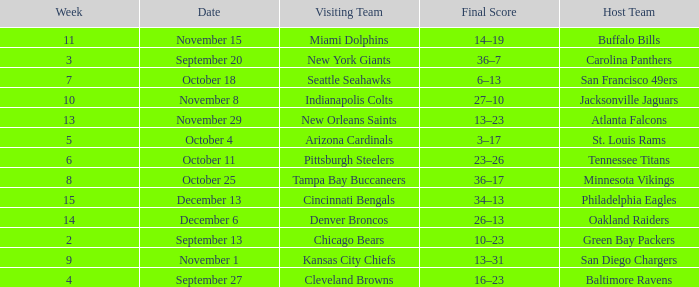What team played on the road against the Buffalo Bills at home ? Miami Dolphins. Could you parse the entire table? {'header': ['Week', 'Date', 'Visiting Team', 'Final Score', 'Host Team'], 'rows': [['11', 'November 15', 'Miami Dolphins', '14–19', 'Buffalo Bills'], ['3', 'September 20', 'New York Giants', '36–7', 'Carolina Panthers'], ['7', 'October 18', 'Seattle Seahawks', '6–13', 'San Francisco 49ers'], ['10', 'November 8', 'Indianapolis Colts', '27–10', 'Jacksonville Jaguars'], ['13', 'November 29', 'New Orleans Saints', '13–23', 'Atlanta Falcons'], ['5', 'October 4', 'Arizona Cardinals', '3–17', 'St. Louis Rams'], ['6', 'October 11', 'Pittsburgh Steelers', '23–26', 'Tennessee Titans'], ['8', 'October 25', 'Tampa Bay Buccaneers', '36–17', 'Minnesota Vikings'], ['15', 'December 13', 'Cincinnati Bengals', '34–13', 'Philadelphia Eagles'], ['14', 'December 6', 'Denver Broncos', '26–13', 'Oakland Raiders'], ['2', 'September 13', 'Chicago Bears', '10–23', 'Green Bay Packers'], ['9', 'November 1', 'Kansas City Chiefs', '13–31', 'San Diego Chargers'], ['4', 'September 27', 'Cleveland Browns', '16–23', 'Baltimore Ravens']]} 